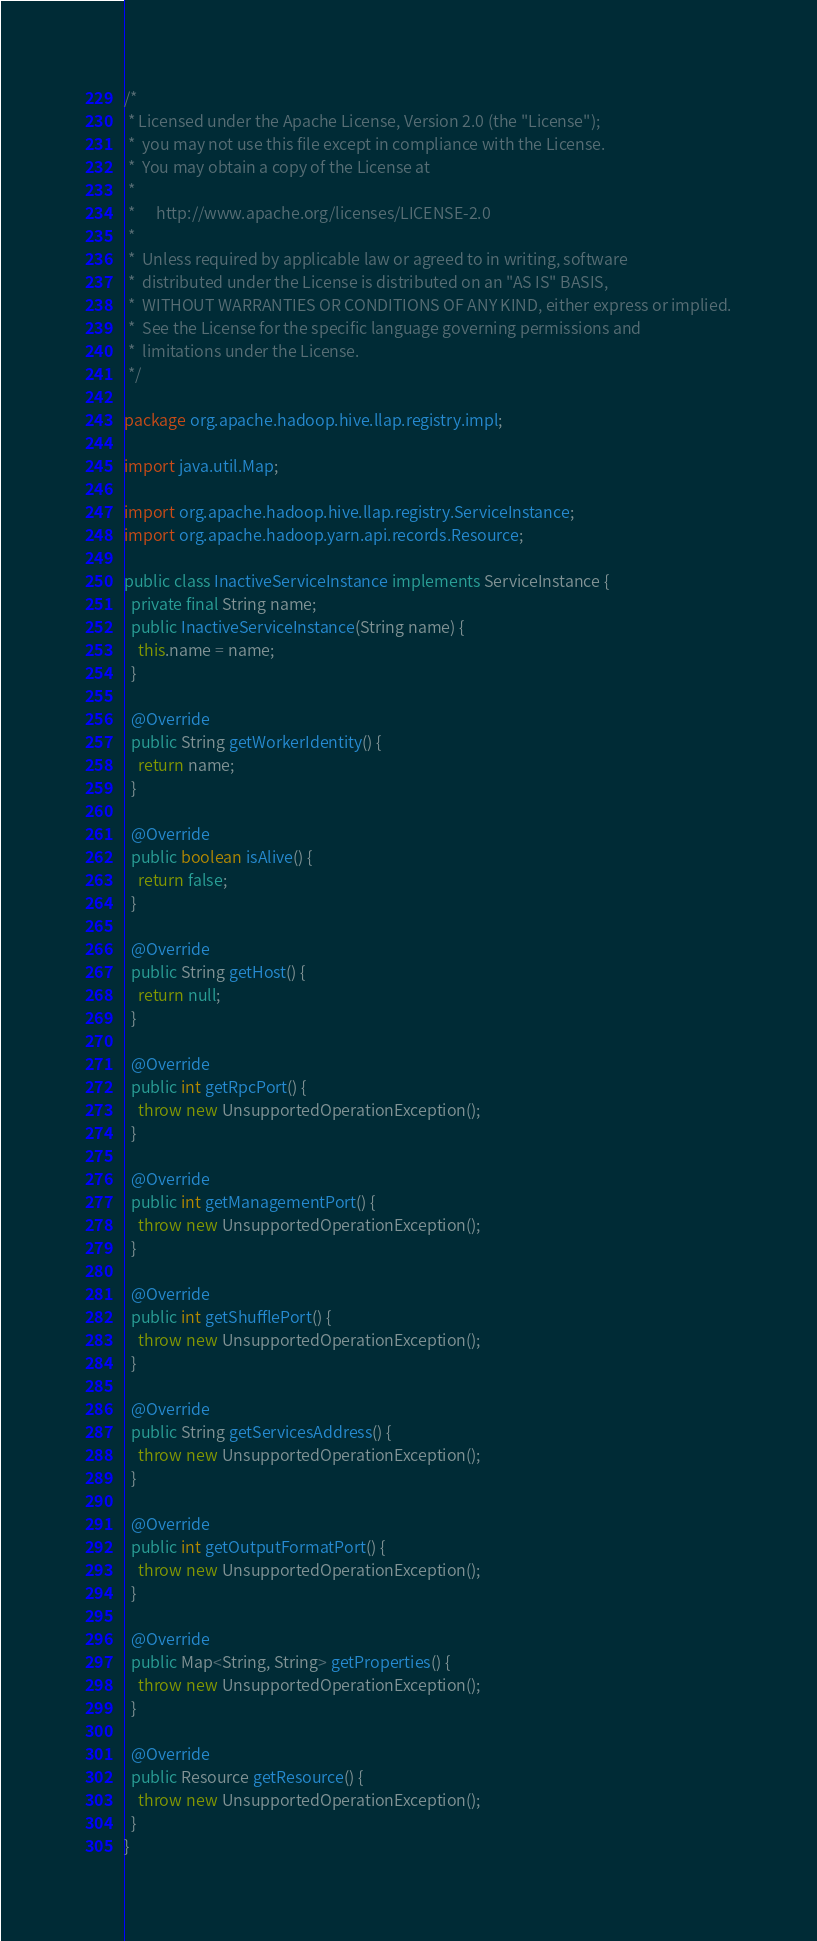Convert code to text. <code><loc_0><loc_0><loc_500><loc_500><_Java_>/*
 * Licensed under the Apache License, Version 2.0 (the "License");
 *  you may not use this file except in compliance with the License.
 *  You may obtain a copy of the License at
 *
 *      http://www.apache.org/licenses/LICENSE-2.0
 *
 *  Unless required by applicable law or agreed to in writing, software
 *  distributed under the License is distributed on an "AS IS" BASIS,
 *  WITHOUT WARRANTIES OR CONDITIONS OF ANY KIND, either express or implied.
 *  See the License for the specific language governing permissions and
 *  limitations under the License.
 */

package org.apache.hadoop.hive.llap.registry.impl;

import java.util.Map;

import org.apache.hadoop.hive.llap.registry.ServiceInstance;
import org.apache.hadoop.yarn.api.records.Resource;

public class InactiveServiceInstance implements ServiceInstance {
  private final String name;
  public InactiveServiceInstance(String name) {
    this.name = name;
  }

  @Override
  public String getWorkerIdentity() {
    return name;
  }

  @Override
  public boolean isAlive() {
    return false;
  }

  @Override
  public String getHost() {
    return null;
  }

  @Override
  public int getRpcPort() {
    throw new UnsupportedOperationException();
  }

  @Override
  public int getManagementPort() {
    throw new UnsupportedOperationException();
  }

  @Override
  public int getShufflePort() {
    throw new UnsupportedOperationException();
  }

  @Override
  public String getServicesAddress() {
    throw new UnsupportedOperationException();
  }

  @Override
  public int getOutputFormatPort() {
    throw new UnsupportedOperationException();
  }

  @Override
  public Map<String, String> getProperties() {
    throw new UnsupportedOperationException();
  }

  @Override
  public Resource getResource() {
    throw new UnsupportedOperationException();
  }
}
</code> 